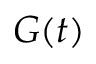<formula> <loc_0><loc_0><loc_500><loc_500>G ( t )</formula> 